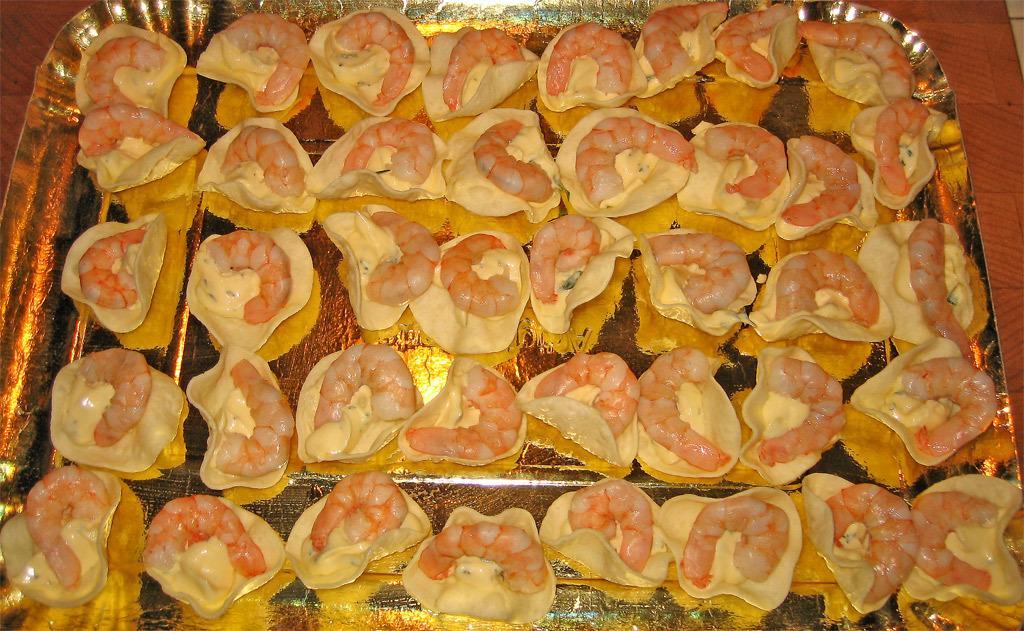How would you summarize this image in a sentence or two? In this picture we can observe number of prawns placed in the plate which is in gold color. The plate was placed on the brown color table. 